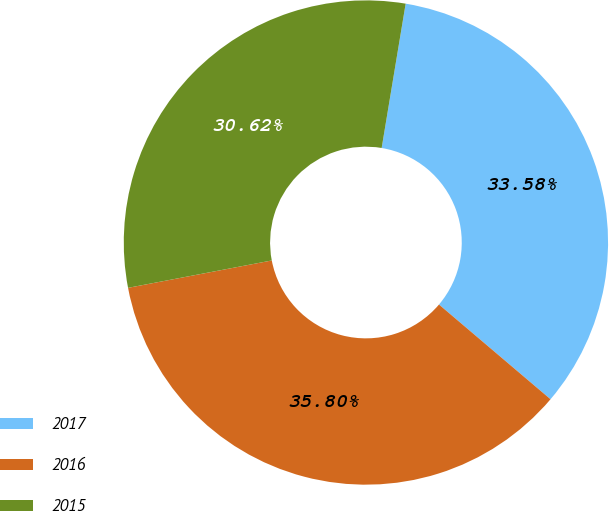Convert chart. <chart><loc_0><loc_0><loc_500><loc_500><pie_chart><fcel>2017<fcel>2016<fcel>2015<nl><fcel>33.58%<fcel>35.8%<fcel>30.62%<nl></chart> 